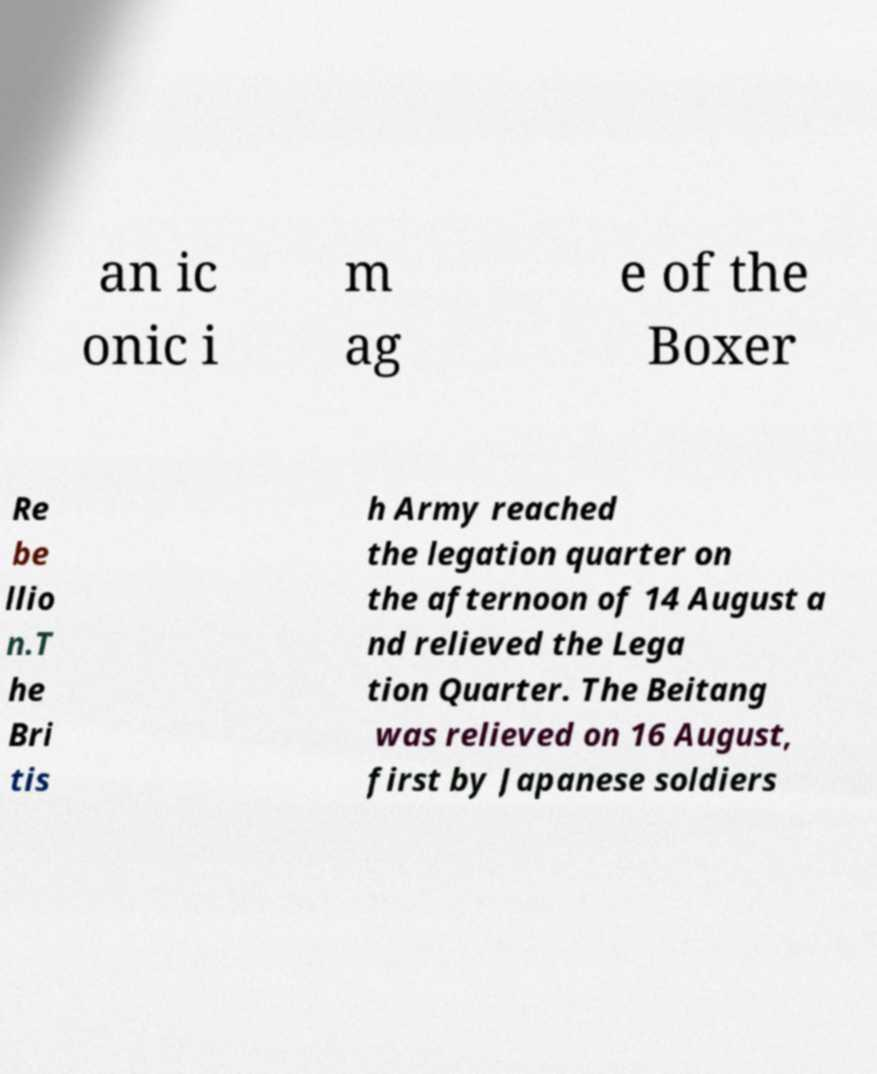There's text embedded in this image that I need extracted. Can you transcribe it verbatim? an ic onic i m ag e of the Boxer Re be llio n.T he Bri tis h Army reached the legation quarter on the afternoon of 14 August a nd relieved the Lega tion Quarter. The Beitang was relieved on 16 August, first by Japanese soldiers 